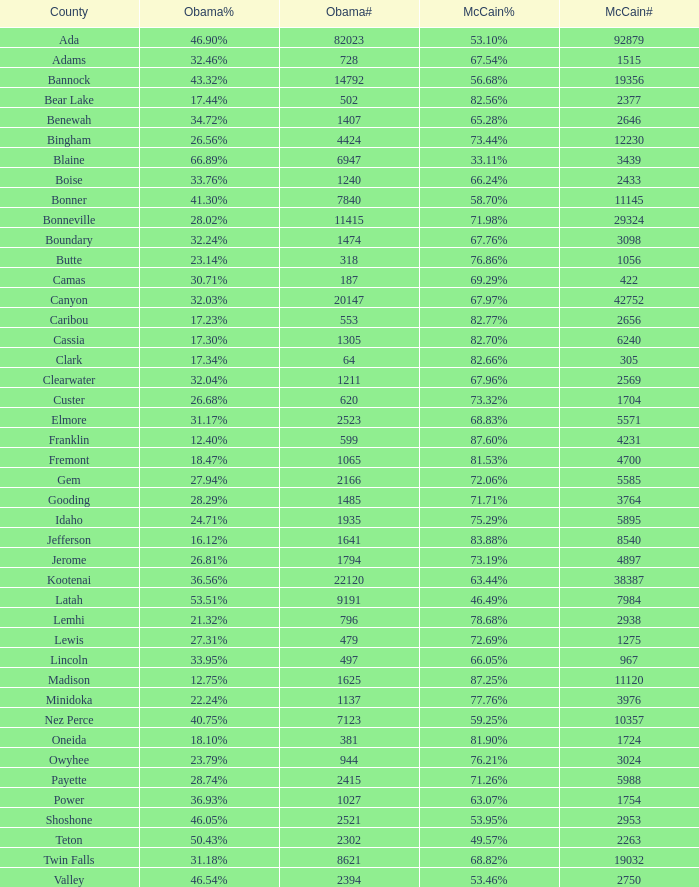In gem county, what was the proportion of votes cast for obama? 27.94%. 